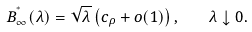<formula> <loc_0><loc_0><loc_500><loc_500>B _ { \infty } ^ { ^ { * } } ( \lambda ) = \sqrt { \lambda } \left ( c _ { \rho } + o ( 1 ) \right ) , \quad \lambda \downarrow 0 .</formula> 